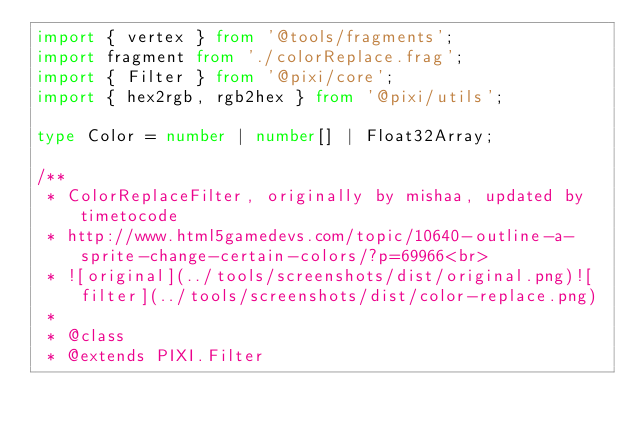<code> <loc_0><loc_0><loc_500><loc_500><_TypeScript_>import { vertex } from '@tools/fragments';
import fragment from './colorReplace.frag';
import { Filter } from '@pixi/core';
import { hex2rgb, rgb2hex } from '@pixi/utils';

type Color = number | number[] | Float32Array;

/**
 * ColorReplaceFilter, originally by mishaa, updated by timetocode
 * http://www.html5gamedevs.com/topic/10640-outline-a-sprite-change-certain-colors/?p=69966<br>
 * ![original](../tools/screenshots/dist/original.png)![filter](../tools/screenshots/dist/color-replace.png)
 *
 * @class
 * @extends PIXI.Filter</code> 